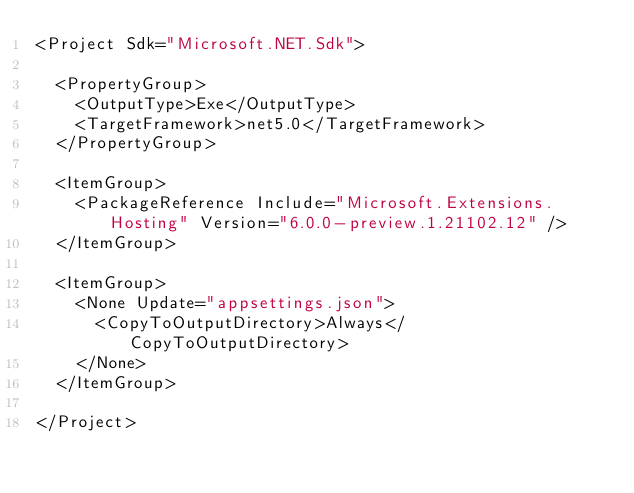<code> <loc_0><loc_0><loc_500><loc_500><_XML_><Project Sdk="Microsoft.NET.Sdk">

  <PropertyGroup>
    <OutputType>Exe</OutputType>
    <TargetFramework>net5.0</TargetFramework>
  </PropertyGroup>

  <ItemGroup>
    <PackageReference Include="Microsoft.Extensions.Hosting" Version="6.0.0-preview.1.21102.12" />
  </ItemGroup>

  <ItemGroup>
    <None Update="appsettings.json">
      <CopyToOutputDirectory>Always</CopyToOutputDirectory>
    </None>
  </ItemGroup>

</Project>
</code> 